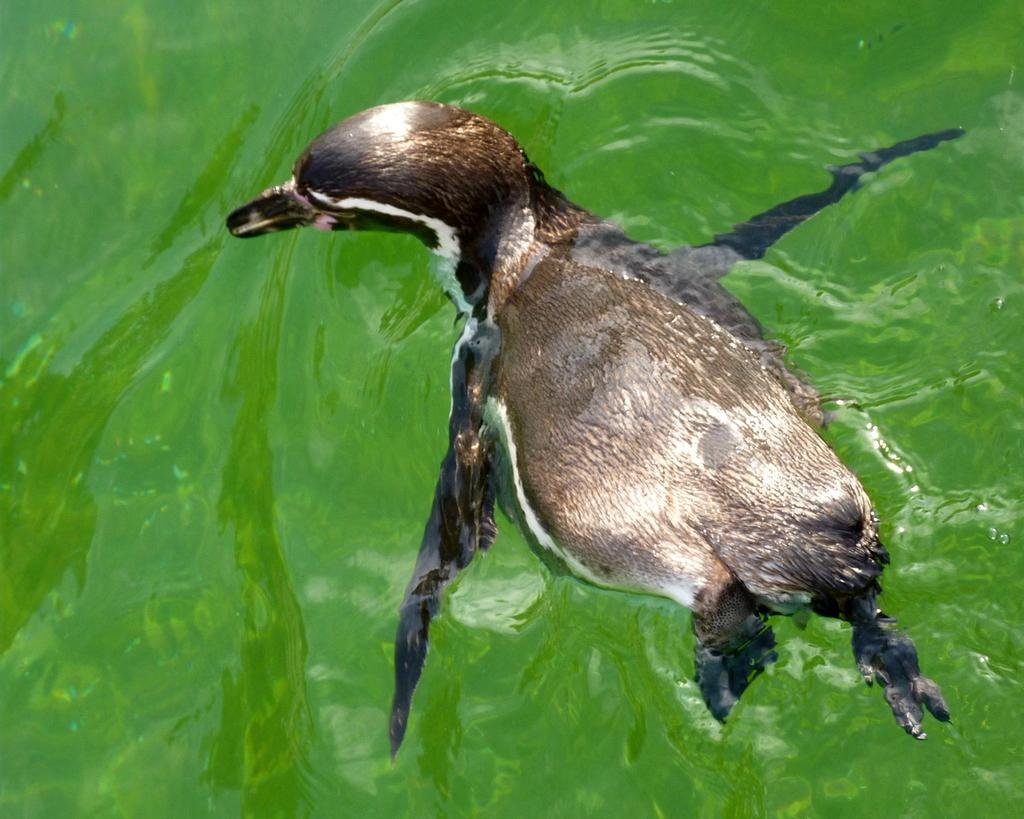What type of animal is in the image? There is an animal in the image, but its specific type cannot be determined from the provided facts. Where is the animal located in the image? The animal is in the water. What colors can be seen on the animal in the image? The animal is black and brown in color. What type of lace is being used to decorate the cat in the image? There is no cat or lace present in the image; it features an animal in the water that is black and brown in color. 